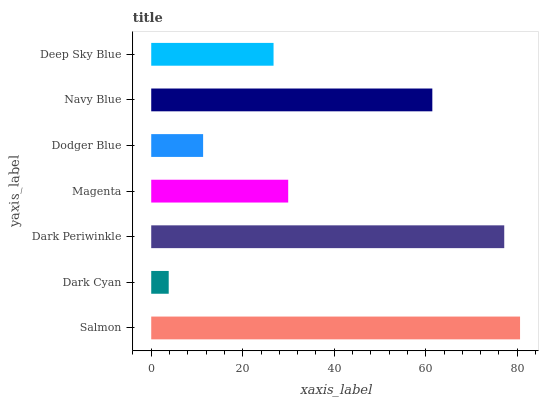Is Dark Cyan the minimum?
Answer yes or no. Yes. Is Salmon the maximum?
Answer yes or no. Yes. Is Dark Periwinkle the minimum?
Answer yes or no. No. Is Dark Periwinkle the maximum?
Answer yes or no. No. Is Dark Periwinkle greater than Dark Cyan?
Answer yes or no. Yes. Is Dark Cyan less than Dark Periwinkle?
Answer yes or no. Yes. Is Dark Cyan greater than Dark Periwinkle?
Answer yes or no. No. Is Dark Periwinkle less than Dark Cyan?
Answer yes or no. No. Is Magenta the high median?
Answer yes or no. Yes. Is Magenta the low median?
Answer yes or no. Yes. Is Dodger Blue the high median?
Answer yes or no. No. Is Salmon the low median?
Answer yes or no. No. 